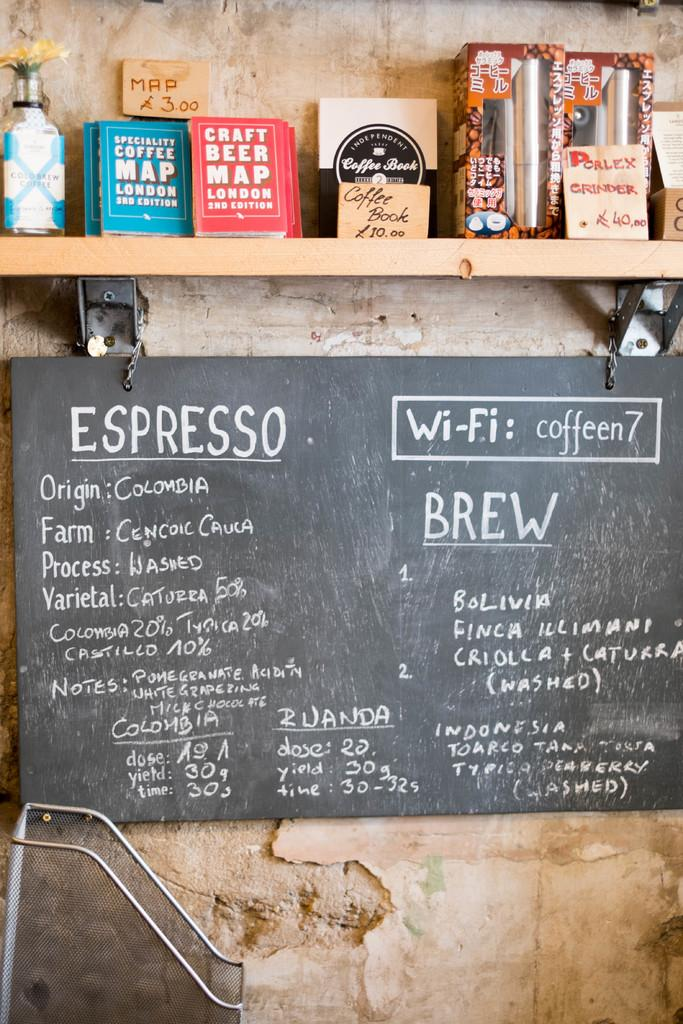Provide a one-sentence caption for the provided image. The coffee shop has a sign about the type of Espresso they serve. 